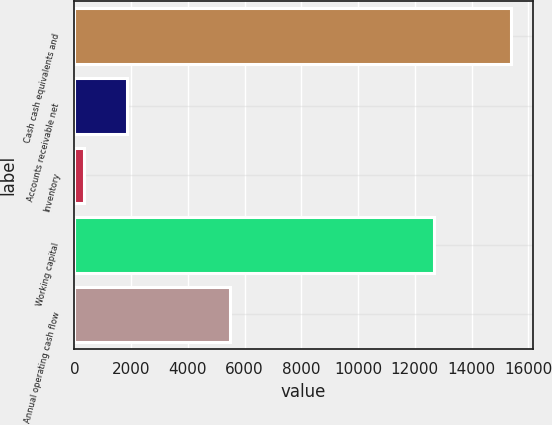<chart> <loc_0><loc_0><loc_500><loc_500><bar_chart><fcel>Cash cash equivalents and<fcel>Accounts receivable net<fcel>Inventory<fcel>Working capital<fcel>Annual operating cash flow<nl><fcel>15386<fcel>1850<fcel>346<fcel>12676<fcel>5470<nl></chart> 